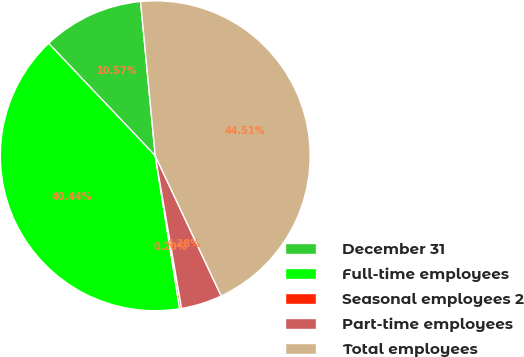Convert chart to OTSL. <chart><loc_0><loc_0><loc_500><loc_500><pie_chart><fcel>December 31<fcel>Full-time employees<fcel>Seasonal employees 2<fcel>Part-time employees<fcel>Total employees<nl><fcel>10.57%<fcel>40.44%<fcel>0.2%<fcel>4.28%<fcel>44.51%<nl></chart> 